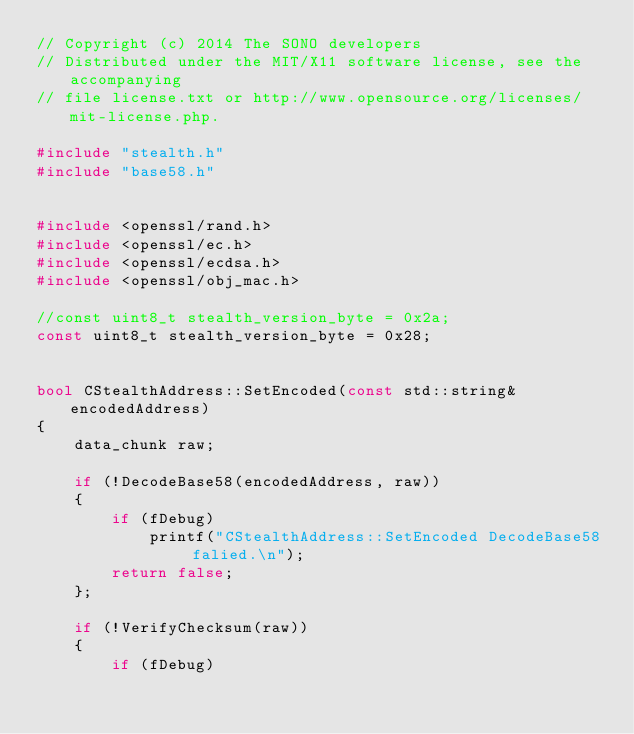Convert code to text. <code><loc_0><loc_0><loc_500><loc_500><_C++_>// Copyright (c) 2014 The SONO developers
// Distributed under the MIT/X11 software license, see the accompanying
// file license.txt or http://www.opensource.org/licenses/mit-license.php.

#include "stealth.h"
#include "base58.h"


#include <openssl/rand.h>
#include <openssl/ec.h>
#include <openssl/ecdsa.h>
#include <openssl/obj_mac.h>

//const uint8_t stealth_version_byte = 0x2a;
const uint8_t stealth_version_byte = 0x28;


bool CStealthAddress::SetEncoded(const std::string& encodedAddress)
{
    data_chunk raw;
    
    if (!DecodeBase58(encodedAddress, raw))
    {
        if (fDebug)
            printf("CStealthAddress::SetEncoded DecodeBase58 falied.\n");
        return false;
    };
    
    if (!VerifyChecksum(raw))
    {
        if (fDebug)</code> 